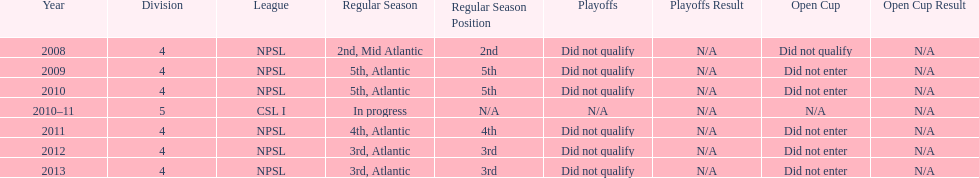Other than npsl, what league has ny mens soccer team played in? CSL I. 